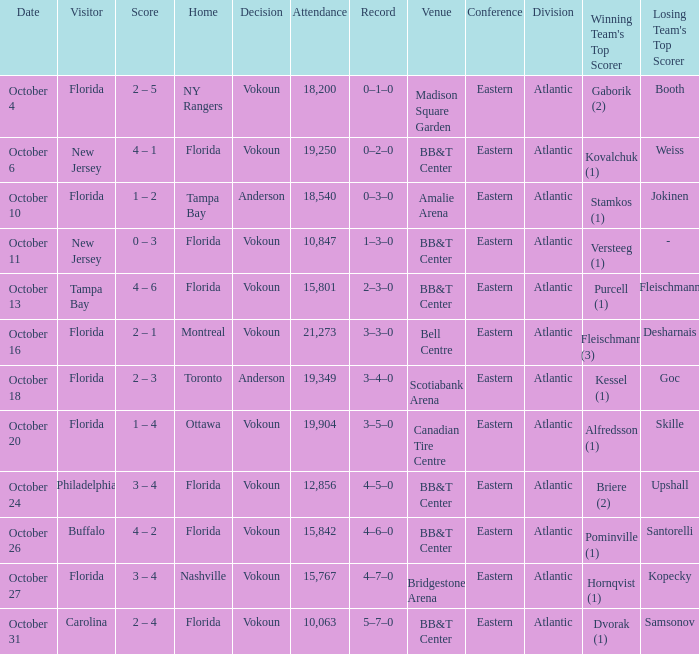Which team was home on October 13? Florida. 